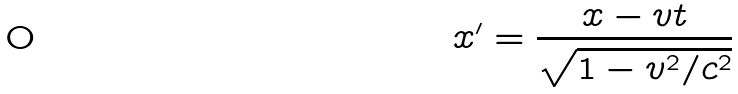<formula> <loc_0><loc_0><loc_500><loc_500>x ^ { \prime } = \frac { x - v t } { \sqrt { 1 - v ^ { 2 } / c ^ { 2 } } }</formula> 